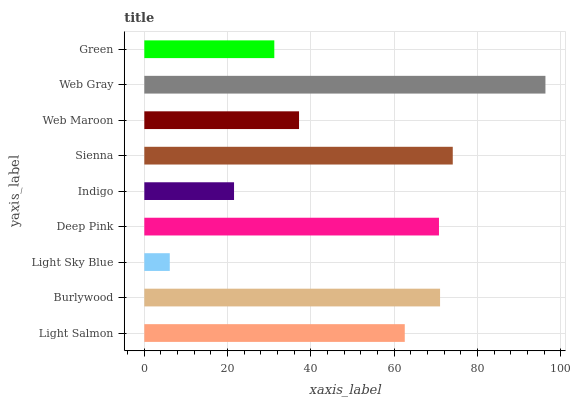Is Light Sky Blue the minimum?
Answer yes or no. Yes. Is Web Gray the maximum?
Answer yes or no. Yes. Is Burlywood the minimum?
Answer yes or no. No. Is Burlywood the maximum?
Answer yes or no. No. Is Burlywood greater than Light Salmon?
Answer yes or no. Yes. Is Light Salmon less than Burlywood?
Answer yes or no. Yes. Is Light Salmon greater than Burlywood?
Answer yes or no. No. Is Burlywood less than Light Salmon?
Answer yes or no. No. Is Light Salmon the high median?
Answer yes or no. Yes. Is Light Salmon the low median?
Answer yes or no. Yes. Is Light Sky Blue the high median?
Answer yes or no. No. Is Green the low median?
Answer yes or no. No. 